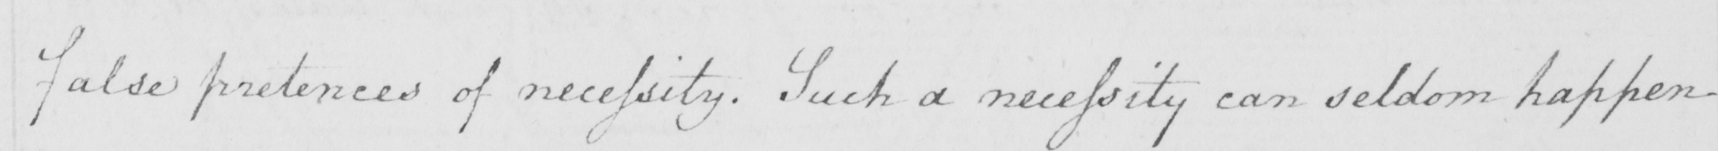Can you read and transcribe this handwriting? false pretenses of necessity . Such a necessity can seldom happen 